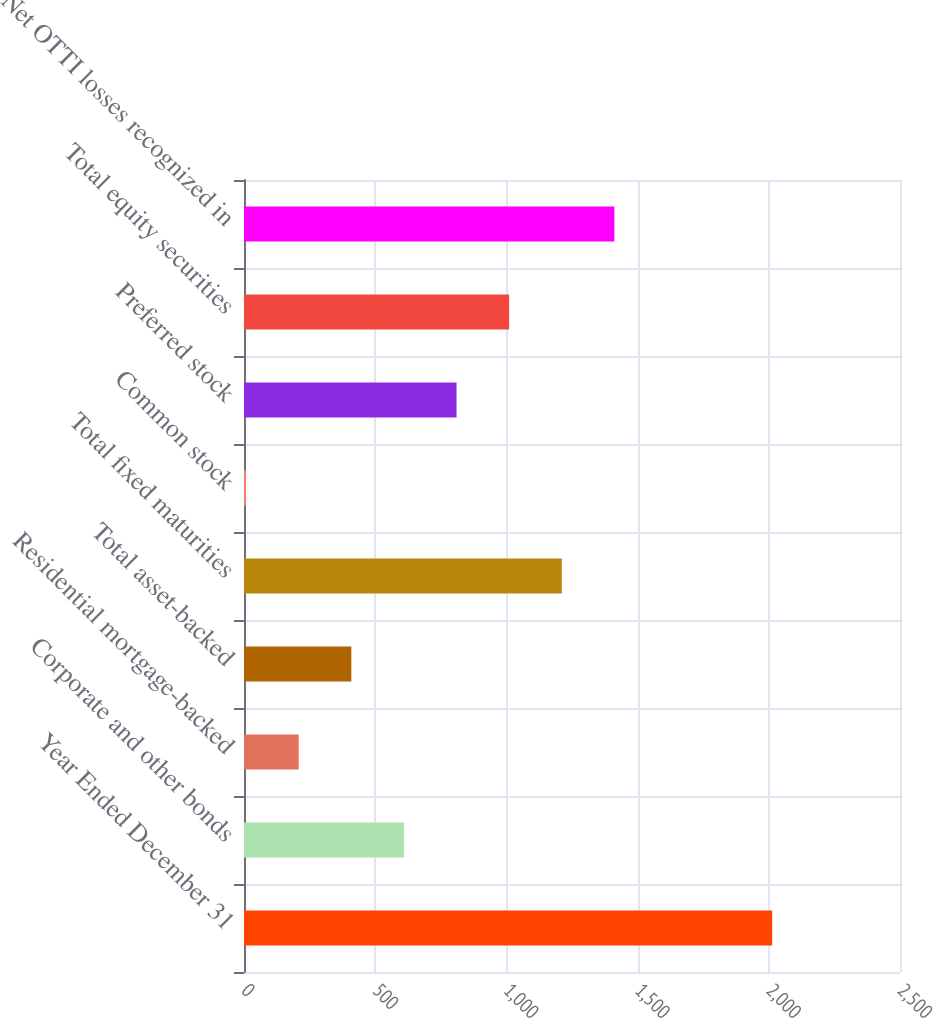Convert chart. <chart><loc_0><loc_0><loc_500><loc_500><bar_chart><fcel>Year Ended December 31<fcel>Corporate and other bonds<fcel>Residential mortgage-backed<fcel>Total asset-backed<fcel>Total fixed maturities<fcel>Common stock<fcel>Preferred stock<fcel>Total equity securities<fcel>Net OTTI losses recognized in<nl><fcel>2013<fcel>609.5<fcel>208.5<fcel>409<fcel>1211<fcel>8<fcel>810<fcel>1010.5<fcel>1411.5<nl></chart> 